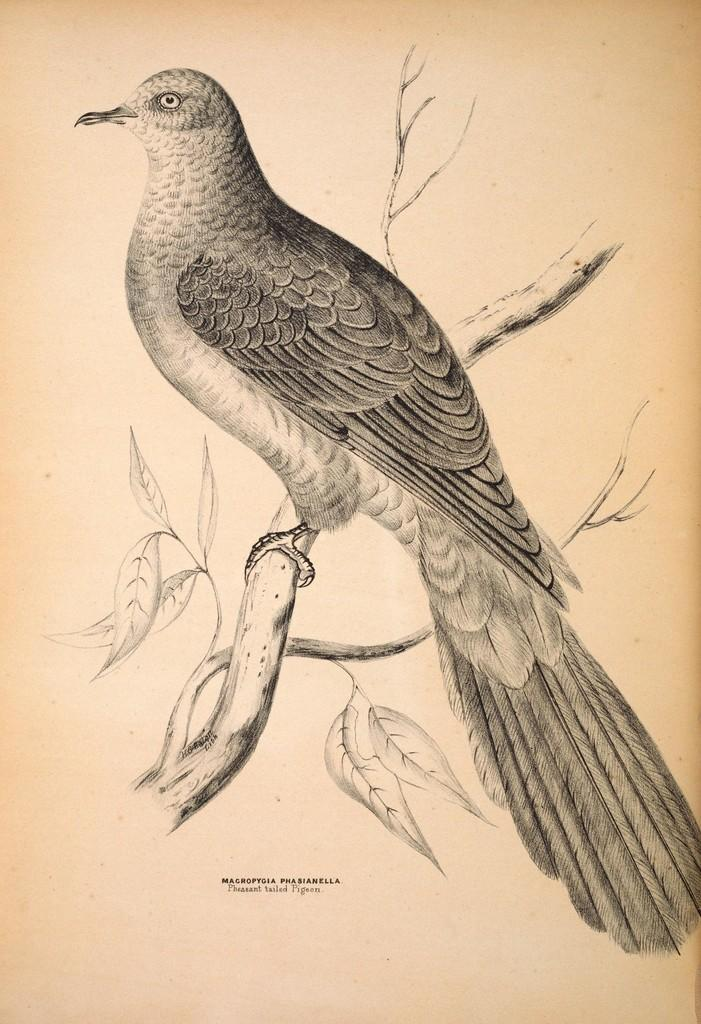What type of artwork is depicted in the image? The image is a drawing. What animal is featured in the drawing? There is a bird in the drawing. What else can be seen in the drawing besides the bird? There are branches and leaves in the drawing. Is there any text present in the image? Yes, there is writing at the bottom portion of the drawing. What time of day is depicted in the drawing? The image does not depict a specific time of day, as it is a drawing of a bird and branches. Can you tell me how many books are in the library shown in the drawing? There is no library depicted in the drawing; it features a bird and branches. 